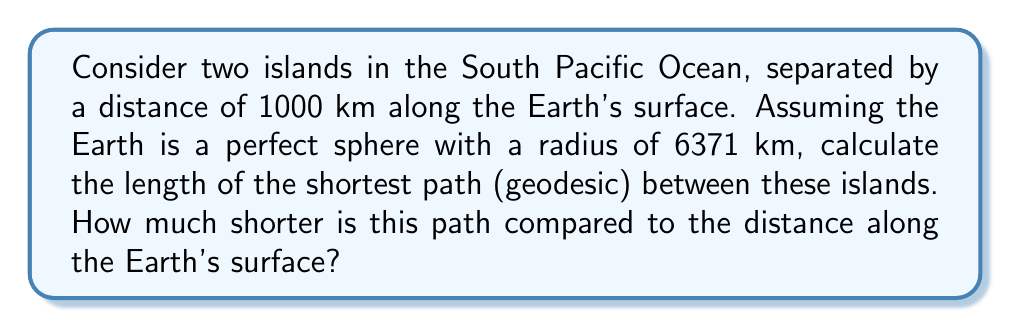Give your solution to this math problem. Let's approach this step-by-step:

1) First, we need to calculate the central angle $\theta$ between the two islands. We can use the arc length formula:

   $s = r\theta$

   Where $s$ is the surface distance (1000 km), $r$ is the Earth's radius (6371 km), and $\theta$ is in radians.

2) Rearranging the formula:

   $\theta = \frac{s}{r} = \frac{1000}{6371} \approx 0.1570$ radians

3) Now, we can use the chord length formula to find the shortest path (geodesic):

   $d = 2r \sin(\frac{\theta}{2})$

   Where $d$ is the chord length (shortest path).

4) Plugging in our values:

   $d = 2 \cdot 6371 \cdot \sin(\frac{0.1570}{2}) \approx 999.32$ km

5) To find how much shorter this path is, we subtract it from the surface distance:

   $1000 - 999.32 = 0.68$ km

6) As a percentage:

   $\frac{0.68}{1000} \cdot 100\% \approx 0.068\%$

[asy]
import geometry;

pair O=(0,0);
real r=5;
draw(circle(O,r));
real theta=0.1570;
pair A=(r*cos(theta),r*sin(theta));
draw(O--A,dashed);
draw(arc(O,r,0,theta*180/pi));
draw(O--(r,0));
label("Earth's center",O,SW);
label("Island A",(r,0),E);
label("Island B",A,NE);
label("Surface path",point(currentpicture,S),S);
label("Geodesic",O--A,NW);
[/asy]
Answer: 999.32 km; 0.68 km (0.068%) shorter 